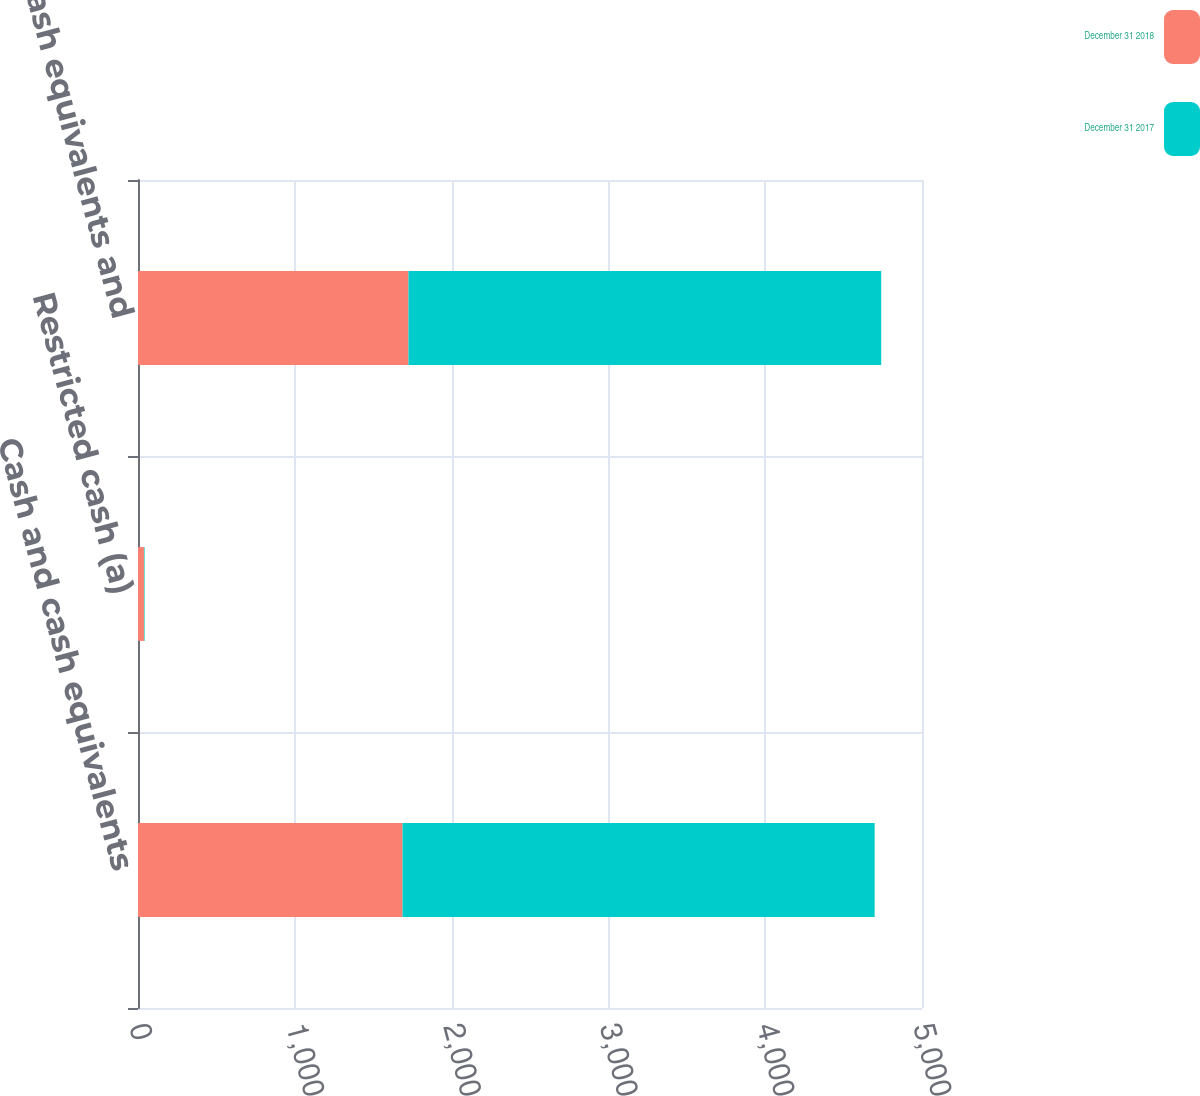Convert chart. <chart><loc_0><loc_0><loc_500><loc_500><stacked_bar_chart><ecel><fcel>Cash and cash equivalents<fcel>Restricted cash (a)<fcel>Cash cash equivalents and<nl><fcel>December 31 2018<fcel>1687<fcel>38<fcel>1725<nl><fcel>December 31 2017<fcel>3011<fcel>4<fcel>3015<nl></chart> 